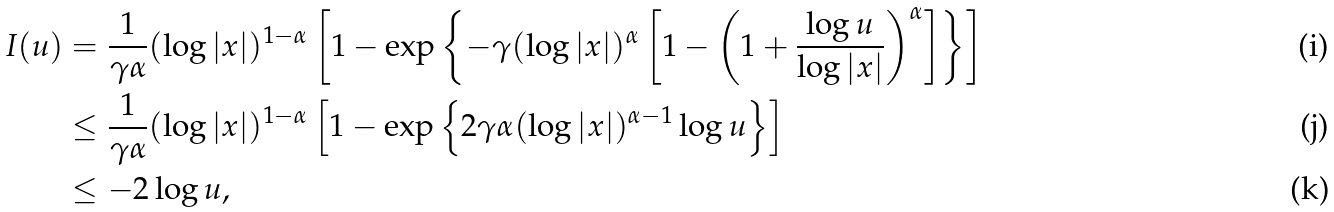<formula> <loc_0><loc_0><loc_500><loc_500>I ( u ) & = \frac { 1 } { \gamma \alpha } ( \log | x | ) ^ { 1 - \alpha } \left [ 1 - \exp \left \{ - \gamma ( \log | x | ) ^ { \alpha } \left [ 1 - \left ( 1 + \frac { \log u } { \log | x | } \right ) ^ { \alpha } \right ] \right \} \right ] \\ & \leq \frac { 1 } { \gamma \alpha } ( \log | x | ) ^ { 1 - \alpha } \left [ 1 - \exp \left \{ 2 \gamma \alpha ( \log | x | ) ^ { \alpha - 1 } \log u \right \} \right ] \\ & \leq - 2 \log u ,</formula> 